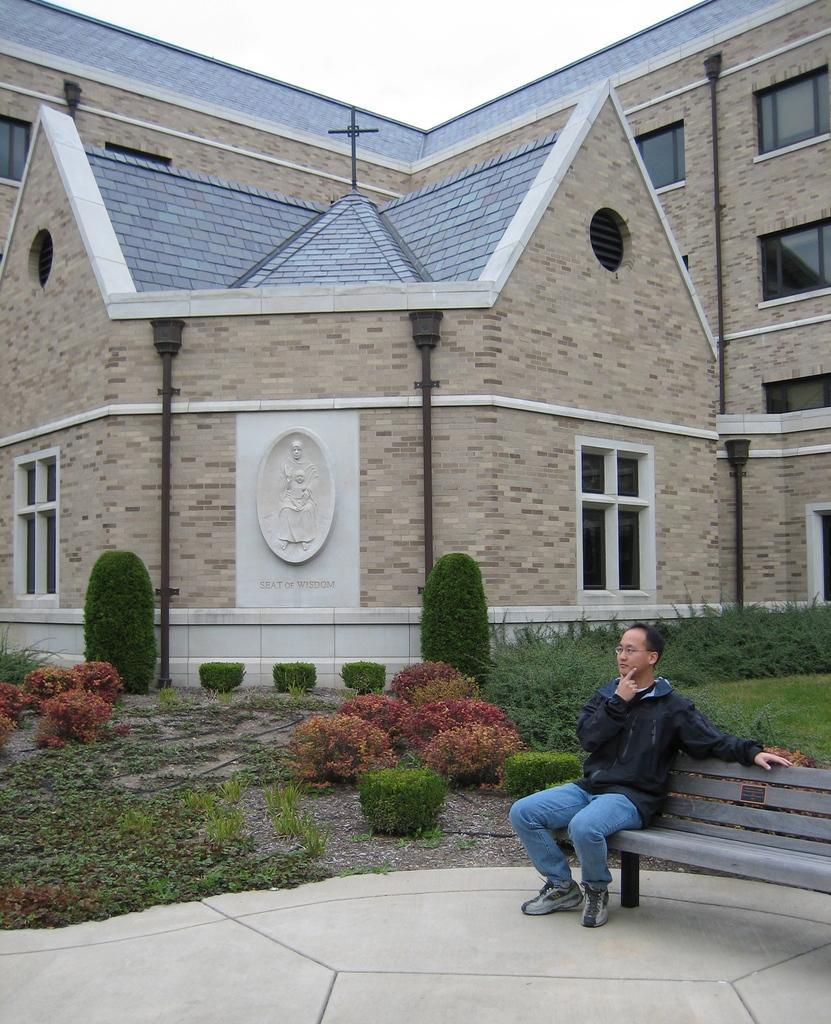Describe this image in one or two sentences. In this image there is a person sitting on the bench. At the back there is a building, at the bottom there are trees and plants. At the top there is a sky and there is a sculpture on the building. 